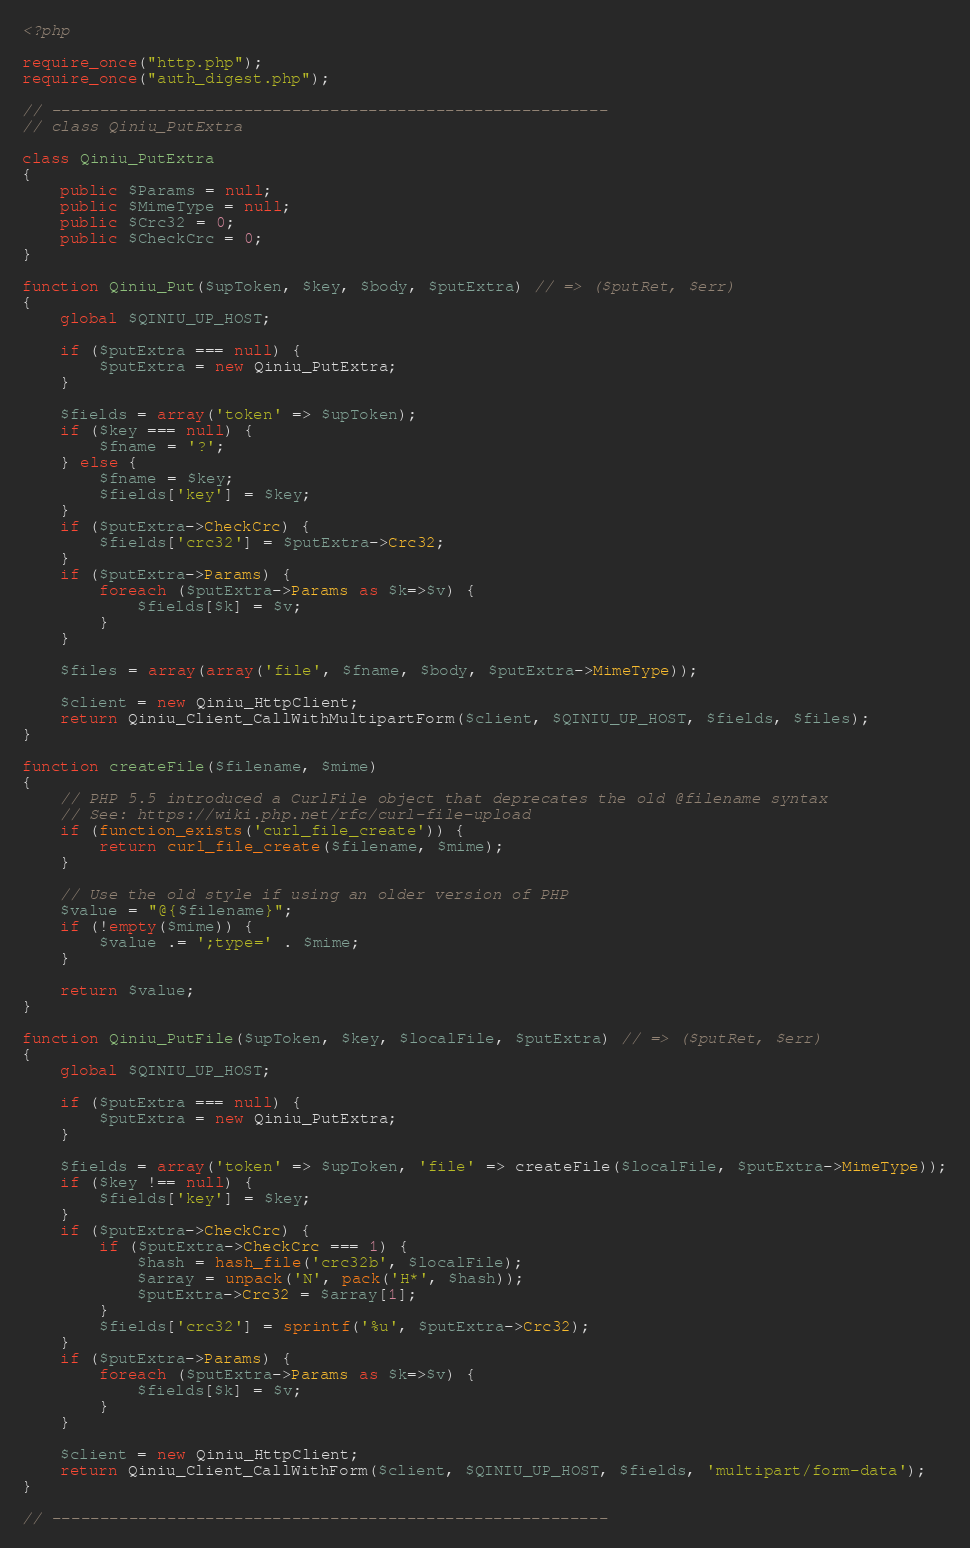<code> <loc_0><loc_0><loc_500><loc_500><_PHP_><?php

require_once("http.php");
require_once("auth_digest.php");

// ----------------------------------------------------------
// class Qiniu_PutExtra

class Qiniu_PutExtra
{
	public $Params = null;
	public $MimeType = null;
	public $Crc32 = 0;
	public $CheckCrc = 0;
}

function Qiniu_Put($upToken, $key, $body, $putExtra) // => ($putRet, $err)
{
	global $QINIU_UP_HOST;

	if ($putExtra === null) {
		$putExtra = new Qiniu_PutExtra;
	}

	$fields = array('token' => $upToken);
	if ($key === null) {
		$fname = '?';
	} else {
		$fname = $key;
		$fields['key'] = $key;
	}
	if ($putExtra->CheckCrc) {
		$fields['crc32'] = $putExtra->Crc32;
	}
	if ($putExtra->Params) {
		foreach ($putExtra->Params as $k=>$v) {
			$fields[$k] = $v;
		}
	}

	$files = array(array('file', $fname, $body, $putExtra->MimeType));

	$client = new Qiniu_HttpClient;
	return Qiniu_Client_CallWithMultipartForm($client, $QINIU_UP_HOST, $fields, $files);
}

function createFile($filename, $mime)
{
    // PHP 5.5 introduced a CurlFile object that deprecates the old @filename syntax
    // See: https://wiki.php.net/rfc/curl-file-upload
    if (function_exists('curl_file_create')) {
        return curl_file_create($filename, $mime);
    }

    // Use the old style if using an older version of PHP
    $value = "@{$filename}";
    if (!empty($mime)) {
        $value .= ';type=' . $mime;
    }

    return $value;
}

function Qiniu_PutFile($upToken, $key, $localFile, $putExtra) // => ($putRet, $err)
{
	global $QINIU_UP_HOST;

	if ($putExtra === null) {
		$putExtra = new Qiniu_PutExtra;
	}

	$fields = array('token' => $upToken, 'file' => createFile($localFile, $putExtra->MimeType));
	if ($key !== null) {
		$fields['key'] = $key;
	}
	if ($putExtra->CheckCrc) {
		if ($putExtra->CheckCrc === 1) {
			$hash = hash_file('crc32b', $localFile);
			$array = unpack('N', pack('H*', $hash));
			$putExtra->Crc32 = $array[1];
		}
		$fields['crc32'] = sprintf('%u', $putExtra->Crc32);
	}
	if ($putExtra->Params) {
		foreach ($putExtra->Params as $k=>$v) {
			$fields[$k] = $v;
		}
	}

	$client = new Qiniu_HttpClient;
	return Qiniu_Client_CallWithForm($client, $QINIU_UP_HOST, $fields, 'multipart/form-data');
}

// ----------------------------------------------------------

</code> 